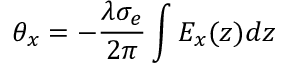<formula> <loc_0><loc_0><loc_500><loc_500>\theta _ { x } = - \frac { \lambda \sigma _ { e } } { 2 \pi } \int { E _ { x } ( z ) } d z</formula> 